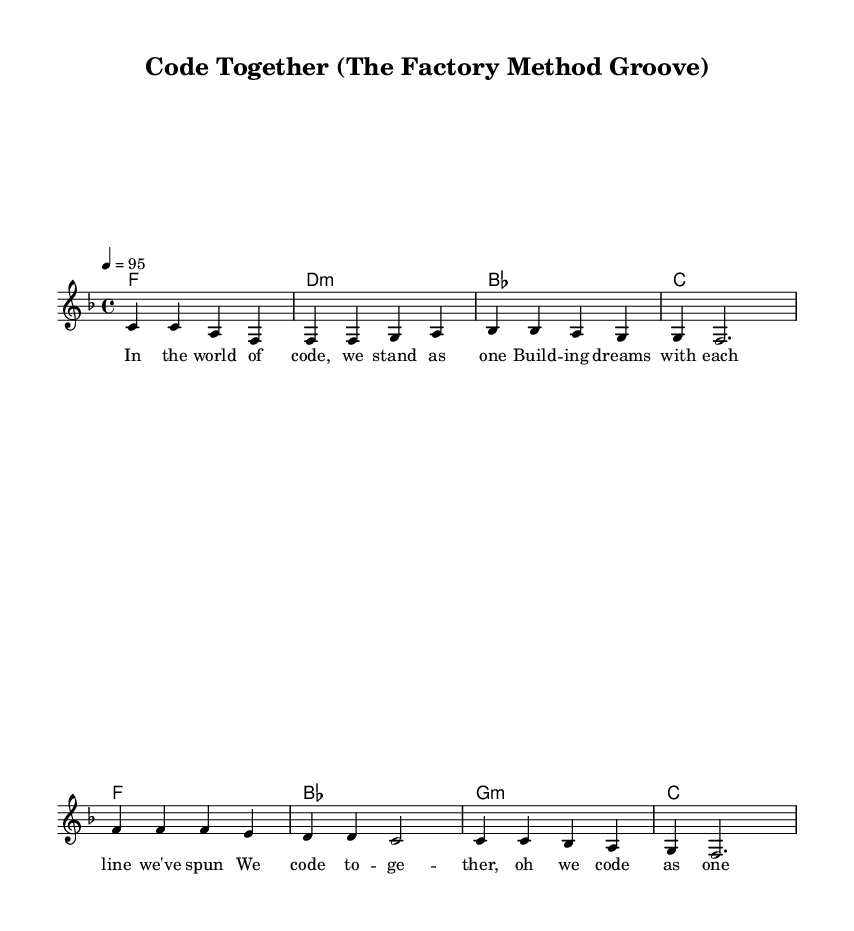What is the key signature of this music? The key signature is indicated by the number of sharps or flats at the beginning of the staff. In this sheet music, there are no sharps or flats, which means it is in the key of F major.
Answer: F major What is the time signature of this music? The time signature is presented at the start of the music, indicating how many beats are in each measure. This music has a 4/4 time signature, meaning there are four beats in each measure.
Answer: 4/4 What is the tempo marking of this song? The tempo marking is given as a number and a note value, stationed above the staff. In this case, it specifies a tempo of 95 beats per minute, represented as 4 = 95.
Answer: 95 How many measures are in the verse section? To determine the number of measures, we count the measures for the verse section in the melody. There are a total of four measures in the verse as represented by notation.
Answer: 4 What type of harmony is used in the chorus section? The harmony is shown through chord symbols above the staff. In the chorus, we see G minor (g:m) and B flat major (bes) chords, indicating a movement through these chord types.
Answer: G minor, B flat major What is the overall theme of the lyrics? The theme can be deduced from the lyrical content, which focuses on collaboration and teamwork in coding projects. It emphasizes unity and the shared effort involved in software development.
Answer: Teamwork What technique is highlighted in the chorus of this piece? The chorus incorporates the "Factory Method," a design pattern that suggests a method of creating instances that are encapsulated, highlighting collaboration in coding.
Answer: Factory Method 